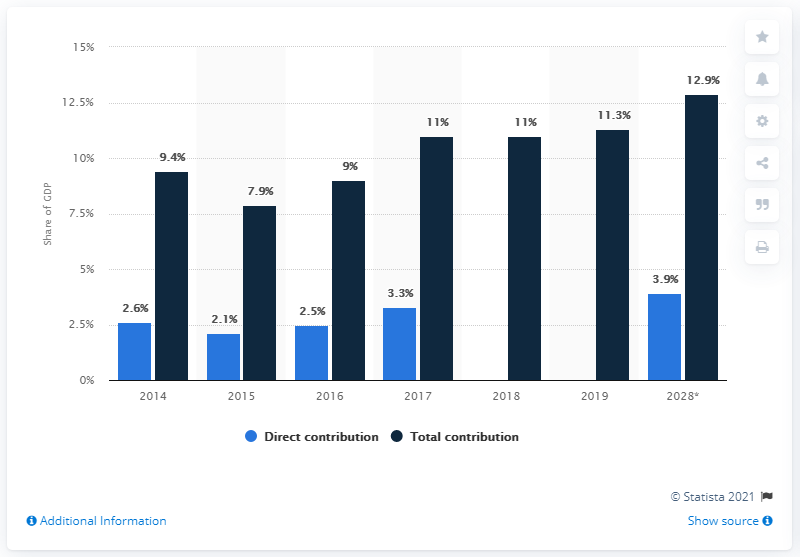Give some essential details in this illustration. In 2017, the total contribution and direct contribution of GDP were 7.7 and 4.2, respectively. According to the total contribution, the forecasted value of GDP in 2028 is projected to be 12.9... In 2019, the travel and tourism industry contributed 11.3% of China's Gross Domestic Product (GDP). 